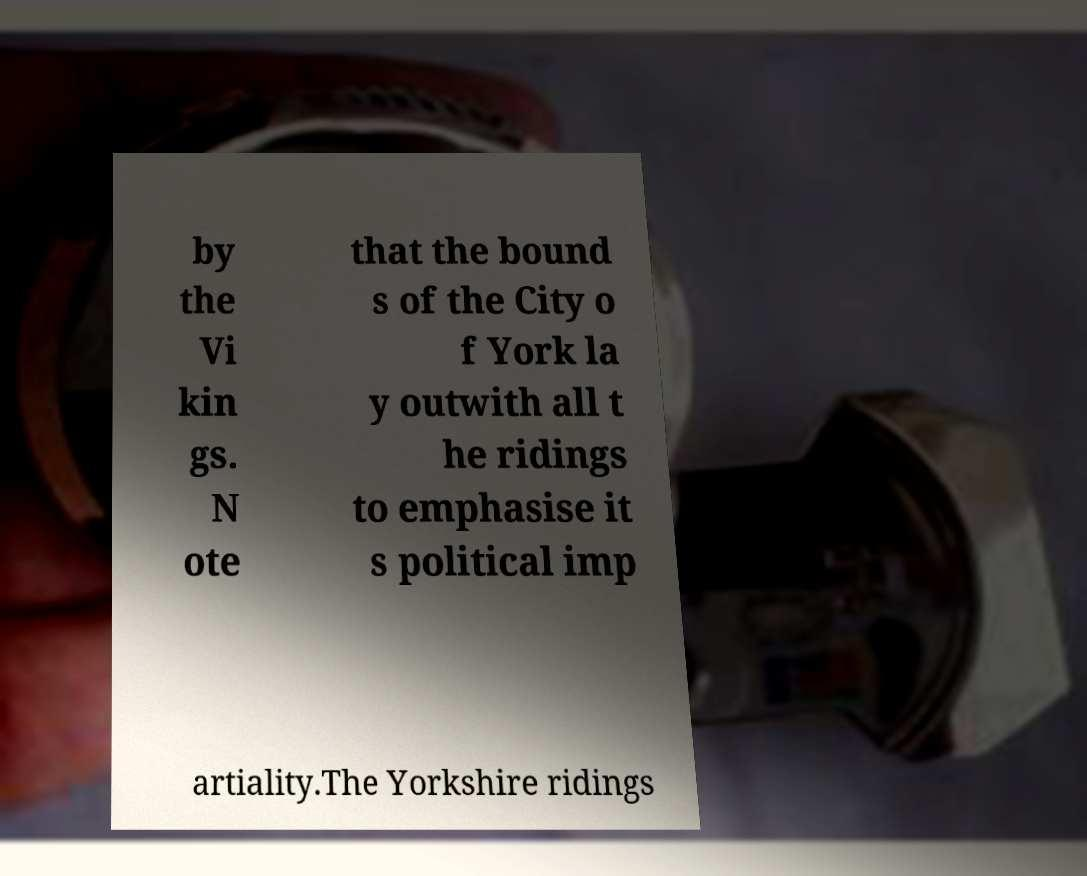Please identify and transcribe the text found in this image. by the Vi kin gs. N ote that the bound s of the City o f York la y outwith all t he ridings to emphasise it s political imp artiality.The Yorkshire ridings 